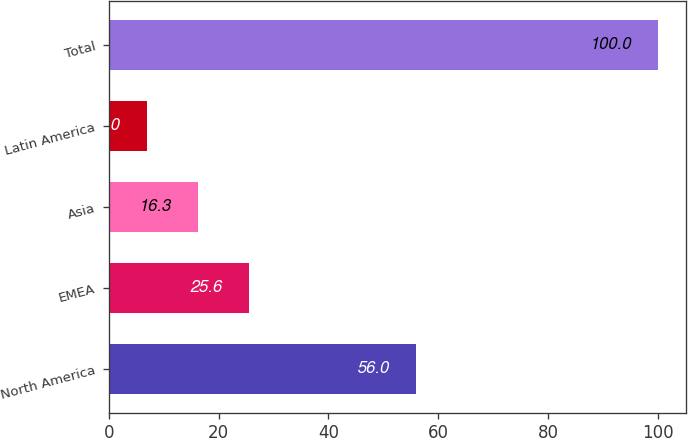Convert chart. <chart><loc_0><loc_0><loc_500><loc_500><bar_chart><fcel>North America<fcel>EMEA<fcel>Asia<fcel>Latin America<fcel>Total<nl><fcel>56<fcel>25.6<fcel>16.3<fcel>7<fcel>100<nl></chart> 